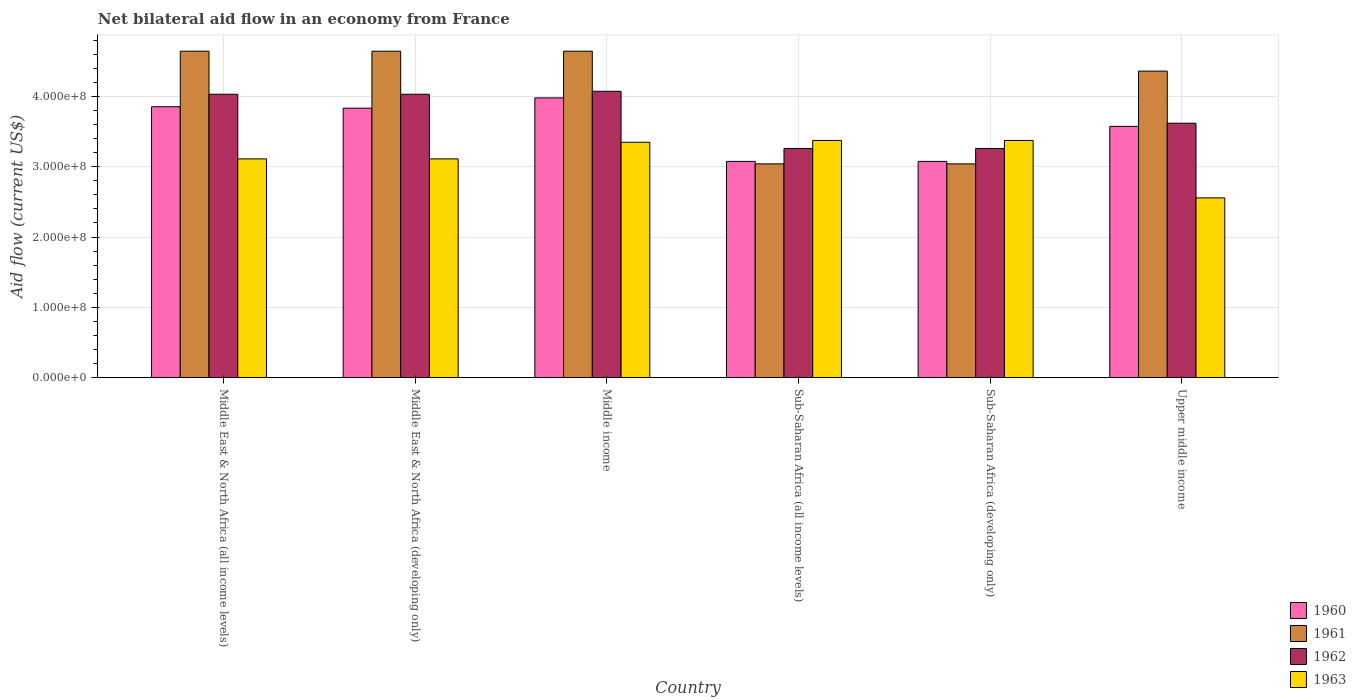How many different coloured bars are there?
Provide a short and direct response. 4. Are the number of bars per tick equal to the number of legend labels?
Your answer should be very brief. Yes. Are the number of bars on each tick of the X-axis equal?
Keep it short and to the point. Yes. How many bars are there on the 3rd tick from the left?
Make the answer very short. 4. What is the label of the 5th group of bars from the left?
Provide a succinct answer. Sub-Saharan Africa (developing only). In how many cases, is the number of bars for a given country not equal to the number of legend labels?
Keep it short and to the point. 0. What is the net bilateral aid flow in 1962 in Middle East & North Africa (developing only)?
Provide a succinct answer. 4.03e+08. Across all countries, what is the maximum net bilateral aid flow in 1960?
Provide a succinct answer. 3.98e+08. Across all countries, what is the minimum net bilateral aid flow in 1960?
Make the answer very short. 3.08e+08. In which country was the net bilateral aid flow in 1961 maximum?
Provide a short and direct response. Middle East & North Africa (all income levels). In which country was the net bilateral aid flow in 1960 minimum?
Give a very brief answer. Sub-Saharan Africa (all income levels). What is the total net bilateral aid flow in 1962 in the graph?
Your response must be concise. 2.23e+09. What is the difference between the net bilateral aid flow in 1960 in Middle East & North Africa (developing only) and that in Upper middle income?
Your answer should be very brief. 2.59e+07. What is the difference between the net bilateral aid flow in 1963 in Middle East & North Africa (all income levels) and the net bilateral aid flow in 1961 in Upper middle income?
Ensure brevity in your answer.  -1.25e+08. What is the average net bilateral aid flow in 1960 per country?
Provide a succinct answer. 3.56e+08. What is the difference between the net bilateral aid flow of/in 1961 and net bilateral aid flow of/in 1962 in Middle East & North Africa (all income levels)?
Your answer should be very brief. 6.12e+07. What is the ratio of the net bilateral aid flow in 1960 in Middle income to that in Upper middle income?
Provide a short and direct response. 1.11. Is the net bilateral aid flow in 1961 in Middle East & North Africa (all income levels) less than that in Sub-Saharan Africa (developing only)?
Make the answer very short. No. Is the difference between the net bilateral aid flow in 1961 in Middle East & North Africa (all income levels) and Middle East & North Africa (developing only) greater than the difference between the net bilateral aid flow in 1962 in Middle East & North Africa (all income levels) and Middle East & North Africa (developing only)?
Give a very brief answer. No. What is the difference between the highest and the second highest net bilateral aid flow in 1962?
Offer a very short reply. 4.20e+06. What is the difference between the highest and the lowest net bilateral aid flow in 1963?
Your response must be concise. 8.17e+07. Is it the case that in every country, the sum of the net bilateral aid flow in 1963 and net bilateral aid flow in 1961 is greater than the sum of net bilateral aid flow in 1962 and net bilateral aid flow in 1960?
Provide a succinct answer. No. How many countries are there in the graph?
Your answer should be very brief. 6. What is the difference between two consecutive major ticks on the Y-axis?
Your response must be concise. 1.00e+08. Are the values on the major ticks of Y-axis written in scientific E-notation?
Provide a short and direct response. Yes. Does the graph contain any zero values?
Make the answer very short. No. Does the graph contain grids?
Your answer should be very brief. Yes. How are the legend labels stacked?
Provide a short and direct response. Vertical. What is the title of the graph?
Your answer should be very brief. Net bilateral aid flow in an economy from France. Does "1998" appear as one of the legend labels in the graph?
Keep it short and to the point. No. What is the label or title of the Y-axis?
Provide a short and direct response. Aid flow (current US$). What is the Aid flow (current US$) in 1960 in Middle East & North Africa (all income levels)?
Give a very brief answer. 3.85e+08. What is the Aid flow (current US$) in 1961 in Middle East & North Africa (all income levels)?
Make the answer very short. 4.64e+08. What is the Aid flow (current US$) of 1962 in Middle East & North Africa (all income levels)?
Provide a succinct answer. 4.03e+08. What is the Aid flow (current US$) of 1963 in Middle East & North Africa (all income levels)?
Provide a short and direct response. 3.11e+08. What is the Aid flow (current US$) in 1960 in Middle East & North Africa (developing only)?
Offer a very short reply. 3.83e+08. What is the Aid flow (current US$) of 1961 in Middle East & North Africa (developing only)?
Ensure brevity in your answer.  4.64e+08. What is the Aid flow (current US$) of 1962 in Middle East & North Africa (developing only)?
Ensure brevity in your answer.  4.03e+08. What is the Aid flow (current US$) of 1963 in Middle East & North Africa (developing only)?
Offer a terse response. 3.11e+08. What is the Aid flow (current US$) of 1960 in Middle income?
Offer a very short reply. 3.98e+08. What is the Aid flow (current US$) of 1961 in Middle income?
Make the answer very short. 4.64e+08. What is the Aid flow (current US$) of 1962 in Middle income?
Provide a succinct answer. 4.07e+08. What is the Aid flow (current US$) in 1963 in Middle income?
Keep it short and to the point. 3.35e+08. What is the Aid flow (current US$) in 1960 in Sub-Saharan Africa (all income levels)?
Ensure brevity in your answer.  3.08e+08. What is the Aid flow (current US$) of 1961 in Sub-Saharan Africa (all income levels)?
Provide a succinct answer. 3.04e+08. What is the Aid flow (current US$) in 1962 in Sub-Saharan Africa (all income levels)?
Provide a succinct answer. 3.26e+08. What is the Aid flow (current US$) in 1963 in Sub-Saharan Africa (all income levels)?
Make the answer very short. 3.37e+08. What is the Aid flow (current US$) of 1960 in Sub-Saharan Africa (developing only)?
Give a very brief answer. 3.08e+08. What is the Aid flow (current US$) in 1961 in Sub-Saharan Africa (developing only)?
Your answer should be very brief. 3.04e+08. What is the Aid flow (current US$) in 1962 in Sub-Saharan Africa (developing only)?
Offer a very short reply. 3.26e+08. What is the Aid flow (current US$) of 1963 in Sub-Saharan Africa (developing only)?
Your response must be concise. 3.37e+08. What is the Aid flow (current US$) in 1960 in Upper middle income?
Ensure brevity in your answer.  3.57e+08. What is the Aid flow (current US$) in 1961 in Upper middle income?
Keep it short and to the point. 4.36e+08. What is the Aid flow (current US$) in 1962 in Upper middle income?
Provide a succinct answer. 3.62e+08. What is the Aid flow (current US$) in 1963 in Upper middle income?
Keep it short and to the point. 2.56e+08. Across all countries, what is the maximum Aid flow (current US$) in 1960?
Offer a very short reply. 3.98e+08. Across all countries, what is the maximum Aid flow (current US$) of 1961?
Keep it short and to the point. 4.64e+08. Across all countries, what is the maximum Aid flow (current US$) in 1962?
Offer a very short reply. 4.07e+08. Across all countries, what is the maximum Aid flow (current US$) of 1963?
Offer a terse response. 3.37e+08. Across all countries, what is the minimum Aid flow (current US$) in 1960?
Keep it short and to the point. 3.08e+08. Across all countries, what is the minimum Aid flow (current US$) in 1961?
Ensure brevity in your answer.  3.04e+08. Across all countries, what is the minimum Aid flow (current US$) in 1962?
Give a very brief answer. 3.26e+08. Across all countries, what is the minimum Aid flow (current US$) of 1963?
Your answer should be very brief. 2.56e+08. What is the total Aid flow (current US$) in 1960 in the graph?
Offer a very short reply. 2.14e+09. What is the total Aid flow (current US$) of 1961 in the graph?
Your response must be concise. 2.44e+09. What is the total Aid flow (current US$) of 1962 in the graph?
Your answer should be very brief. 2.23e+09. What is the total Aid flow (current US$) of 1963 in the graph?
Provide a short and direct response. 1.89e+09. What is the difference between the Aid flow (current US$) of 1962 in Middle East & North Africa (all income levels) and that in Middle East & North Africa (developing only)?
Your answer should be compact. 0. What is the difference between the Aid flow (current US$) of 1963 in Middle East & North Africa (all income levels) and that in Middle East & North Africa (developing only)?
Make the answer very short. 0. What is the difference between the Aid flow (current US$) in 1960 in Middle East & North Africa (all income levels) and that in Middle income?
Ensure brevity in your answer.  -1.26e+07. What is the difference between the Aid flow (current US$) in 1961 in Middle East & North Africa (all income levels) and that in Middle income?
Give a very brief answer. 0. What is the difference between the Aid flow (current US$) in 1962 in Middle East & North Africa (all income levels) and that in Middle income?
Ensure brevity in your answer.  -4.20e+06. What is the difference between the Aid flow (current US$) of 1963 in Middle East & North Africa (all income levels) and that in Middle income?
Ensure brevity in your answer.  -2.36e+07. What is the difference between the Aid flow (current US$) of 1960 in Middle East & North Africa (all income levels) and that in Sub-Saharan Africa (all income levels)?
Offer a very short reply. 7.77e+07. What is the difference between the Aid flow (current US$) in 1961 in Middle East & North Africa (all income levels) and that in Sub-Saharan Africa (all income levels)?
Offer a very short reply. 1.60e+08. What is the difference between the Aid flow (current US$) of 1962 in Middle East & North Africa (all income levels) and that in Sub-Saharan Africa (all income levels)?
Offer a very short reply. 7.71e+07. What is the difference between the Aid flow (current US$) of 1963 in Middle East & North Africa (all income levels) and that in Sub-Saharan Africa (all income levels)?
Offer a very short reply. -2.62e+07. What is the difference between the Aid flow (current US$) of 1960 in Middle East & North Africa (all income levels) and that in Sub-Saharan Africa (developing only)?
Provide a short and direct response. 7.77e+07. What is the difference between the Aid flow (current US$) of 1961 in Middle East & North Africa (all income levels) and that in Sub-Saharan Africa (developing only)?
Ensure brevity in your answer.  1.60e+08. What is the difference between the Aid flow (current US$) in 1962 in Middle East & North Africa (all income levels) and that in Sub-Saharan Africa (developing only)?
Provide a short and direct response. 7.71e+07. What is the difference between the Aid flow (current US$) in 1963 in Middle East & North Africa (all income levels) and that in Sub-Saharan Africa (developing only)?
Ensure brevity in your answer.  -2.62e+07. What is the difference between the Aid flow (current US$) in 1960 in Middle East & North Africa (all income levels) and that in Upper middle income?
Keep it short and to the point. 2.79e+07. What is the difference between the Aid flow (current US$) in 1961 in Middle East & North Africa (all income levels) and that in Upper middle income?
Provide a succinct answer. 2.83e+07. What is the difference between the Aid flow (current US$) of 1962 in Middle East & North Africa (all income levels) and that in Upper middle income?
Your answer should be very brief. 4.12e+07. What is the difference between the Aid flow (current US$) in 1963 in Middle East & North Africa (all income levels) and that in Upper middle income?
Offer a very short reply. 5.55e+07. What is the difference between the Aid flow (current US$) of 1960 in Middle East & North Africa (developing only) and that in Middle income?
Your answer should be very brief. -1.46e+07. What is the difference between the Aid flow (current US$) in 1962 in Middle East & North Africa (developing only) and that in Middle income?
Your response must be concise. -4.20e+06. What is the difference between the Aid flow (current US$) in 1963 in Middle East & North Africa (developing only) and that in Middle income?
Your answer should be very brief. -2.36e+07. What is the difference between the Aid flow (current US$) of 1960 in Middle East & North Africa (developing only) and that in Sub-Saharan Africa (all income levels)?
Give a very brief answer. 7.57e+07. What is the difference between the Aid flow (current US$) in 1961 in Middle East & North Africa (developing only) and that in Sub-Saharan Africa (all income levels)?
Ensure brevity in your answer.  1.60e+08. What is the difference between the Aid flow (current US$) in 1962 in Middle East & North Africa (developing only) and that in Sub-Saharan Africa (all income levels)?
Give a very brief answer. 7.71e+07. What is the difference between the Aid flow (current US$) of 1963 in Middle East & North Africa (developing only) and that in Sub-Saharan Africa (all income levels)?
Ensure brevity in your answer.  -2.62e+07. What is the difference between the Aid flow (current US$) of 1960 in Middle East & North Africa (developing only) and that in Sub-Saharan Africa (developing only)?
Your answer should be compact. 7.57e+07. What is the difference between the Aid flow (current US$) in 1961 in Middle East & North Africa (developing only) and that in Sub-Saharan Africa (developing only)?
Your answer should be compact. 1.60e+08. What is the difference between the Aid flow (current US$) in 1962 in Middle East & North Africa (developing only) and that in Sub-Saharan Africa (developing only)?
Provide a succinct answer. 7.71e+07. What is the difference between the Aid flow (current US$) in 1963 in Middle East & North Africa (developing only) and that in Sub-Saharan Africa (developing only)?
Give a very brief answer. -2.62e+07. What is the difference between the Aid flow (current US$) in 1960 in Middle East & North Africa (developing only) and that in Upper middle income?
Provide a short and direct response. 2.59e+07. What is the difference between the Aid flow (current US$) in 1961 in Middle East & North Africa (developing only) and that in Upper middle income?
Keep it short and to the point. 2.83e+07. What is the difference between the Aid flow (current US$) in 1962 in Middle East & North Africa (developing only) and that in Upper middle income?
Provide a short and direct response. 4.12e+07. What is the difference between the Aid flow (current US$) of 1963 in Middle East & North Africa (developing only) and that in Upper middle income?
Keep it short and to the point. 5.55e+07. What is the difference between the Aid flow (current US$) of 1960 in Middle income and that in Sub-Saharan Africa (all income levels)?
Give a very brief answer. 9.03e+07. What is the difference between the Aid flow (current US$) in 1961 in Middle income and that in Sub-Saharan Africa (all income levels)?
Give a very brief answer. 1.60e+08. What is the difference between the Aid flow (current US$) of 1962 in Middle income and that in Sub-Saharan Africa (all income levels)?
Give a very brief answer. 8.13e+07. What is the difference between the Aid flow (current US$) in 1963 in Middle income and that in Sub-Saharan Africa (all income levels)?
Make the answer very short. -2.60e+06. What is the difference between the Aid flow (current US$) in 1960 in Middle income and that in Sub-Saharan Africa (developing only)?
Keep it short and to the point. 9.03e+07. What is the difference between the Aid flow (current US$) of 1961 in Middle income and that in Sub-Saharan Africa (developing only)?
Your answer should be compact. 1.60e+08. What is the difference between the Aid flow (current US$) in 1962 in Middle income and that in Sub-Saharan Africa (developing only)?
Give a very brief answer. 8.13e+07. What is the difference between the Aid flow (current US$) in 1963 in Middle income and that in Sub-Saharan Africa (developing only)?
Your answer should be compact. -2.60e+06. What is the difference between the Aid flow (current US$) in 1960 in Middle income and that in Upper middle income?
Your answer should be very brief. 4.05e+07. What is the difference between the Aid flow (current US$) of 1961 in Middle income and that in Upper middle income?
Ensure brevity in your answer.  2.83e+07. What is the difference between the Aid flow (current US$) of 1962 in Middle income and that in Upper middle income?
Provide a short and direct response. 4.54e+07. What is the difference between the Aid flow (current US$) in 1963 in Middle income and that in Upper middle income?
Offer a terse response. 7.91e+07. What is the difference between the Aid flow (current US$) of 1960 in Sub-Saharan Africa (all income levels) and that in Sub-Saharan Africa (developing only)?
Offer a very short reply. 0. What is the difference between the Aid flow (current US$) in 1961 in Sub-Saharan Africa (all income levels) and that in Sub-Saharan Africa (developing only)?
Make the answer very short. 0. What is the difference between the Aid flow (current US$) in 1962 in Sub-Saharan Africa (all income levels) and that in Sub-Saharan Africa (developing only)?
Keep it short and to the point. 0. What is the difference between the Aid flow (current US$) in 1960 in Sub-Saharan Africa (all income levels) and that in Upper middle income?
Your answer should be compact. -4.98e+07. What is the difference between the Aid flow (current US$) of 1961 in Sub-Saharan Africa (all income levels) and that in Upper middle income?
Provide a short and direct response. -1.32e+08. What is the difference between the Aid flow (current US$) of 1962 in Sub-Saharan Africa (all income levels) and that in Upper middle income?
Offer a terse response. -3.59e+07. What is the difference between the Aid flow (current US$) of 1963 in Sub-Saharan Africa (all income levels) and that in Upper middle income?
Offer a very short reply. 8.17e+07. What is the difference between the Aid flow (current US$) in 1960 in Sub-Saharan Africa (developing only) and that in Upper middle income?
Your answer should be very brief. -4.98e+07. What is the difference between the Aid flow (current US$) of 1961 in Sub-Saharan Africa (developing only) and that in Upper middle income?
Give a very brief answer. -1.32e+08. What is the difference between the Aid flow (current US$) in 1962 in Sub-Saharan Africa (developing only) and that in Upper middle income?
Ensure brevity in your answer.  -3.59e+07. What is the difference between the Aid flow (current US$) in 1963 in Sub-Saharan Africa (developing only) and that in Upper middle income?
Ensure brevity in your answer.  8.17e+07. What is the difference between the Aid flow (current US$) in 1960 in Middle East & North Africa (all income levels) and the Aid flow (current US$) in 1961 in Middle East & North Africa (developing only)?
Your answer should be compact. -7.90e+07. What is the difference between the Aid flow (current US$) of 1960 in Middle East & North Africa (all income levels) and the Aid flow (current US$) of 1962 in Middle East & North Africa (developing only)?
Ensure brevity in your answer.  -1.78e+07. What is the difference between the Aid flow (current US$) in 1960 in Middle East & North Africa (all income levels) and the Aid flow (current US$) in 1963 in Middle East & North Africa (developing only)?
Your answer should be very brief. 7.41e+07. What is the difference between the Aid flow (current US$) of 1961 in Middle East & North Africa (all income levels) and the Aid flow (current US$) of 1962 in Middle East & North Africa (developing only)?
Your response must be concise. 6.12e+07. What is the difference between the Aid flow (current US$) in 1961 in Middle East & North Africa (all income levels) and the Aid flow (current US$) in 1963 in Middle East & North Africa (developing only)?
Your answer should be compact. 1.53e+08. What is the difference between the Aid flow (current US$) of 1962 in Middle East & North Africa (all income levels) and the Aid flow (current US$) of 1963 in Middle East & North Africa (developing only)?
Provide a short and direct response. 9.19e+07. What is the difference between the Aid flow (current US$) in 1960 in Middle East & North Africa (all income levels) and the Aid flow (current US$) in 1961 in Middle income?
Your answer should be very brief. -7.90e+07. What is the difference between the Aid flow (current US$) of 1960 in Middle East & North Africa (all income levels) and the Aid flow (current US$) of 1962 in Middle income?
Ensure brevity in your answer.  -2.20e+07. What is the difference between the Aid flow (current US$) of 1960 in Middle East & North Africa (all income levels) and the Aid flow (current US$) of 1963 in Middle income?
Offer a terse response. 5.05e+07. What is the difference between the Aid flow (current US$) in 1961 in Middle East & North Africa (all income levels) and the Aid flow (current US$) in 1962 in Middle income?
Give a very brief answer. 5.70e+07. What is the difference between the Aid flow (current US$) in 1961 in Middle East & North Africa (all income levels) and the Aid flow (current US$) in 1963 in Middle income?
Your response must be concise. 1.30e+08. What is the difference between the Aid flow (current US$) of 1962 in Middle East & North Africa (all income levels) and the Aid flow (current US$) of 1963 in Middle income?
Offer a terse response. 6.83e+07. What is the difference between the Aid flow (current US$) in 1960 in Middle East & North Africa (all income levels) and the Aid flow (current US$) in 1961 in Sub-Saharan Africa (all income levels)?
Ensure brevity in your answer.  8.12e+07. What is the difference between the Aid flow (current US$) of 1960 in Middle East & North Africa (all income levels) and the Aid flow (current US$) of 1962 in Sub-Saharan Africa (all income levels)?
Give a very brief answer. 5.93e+07. What is the difference between the Aid flow (current US$) of 1960 in Middle East & North Africa (all income levels) and the Aid flow (current US$) of 1963 in Sub-Saharan Africa (all income levels)?
Provide a short and direct response. 4.79e+07. What is the difference between the Aid flow (current US$) in 1961 in Middle East & North Africa (all income levels) and the Aid flow (current US$) in 1962 in Sub-Saharan Africa (all income levels)?
Make the answer very short. 1.38e+08. What is the difference between the Aid flow (current US$) of 1961 in Middle East & North Africa (all income levels) and the Aid flow (current US$) of 1963 in Sub-Saharan Africa (all income levels)?
Provide a succinct answer. 1.27e+08. What is the difference between the Aid flow (current US$) of 1962 in Middle East & North Africa (all income levels) and the Aid flow (current US$) of 1963 in Sub-Saharan Africa (all income levels)?
Offer a very short reply. 6.57e+07. What is the difference between the Aid flow (current US$) in 1960 in Middle East & North Africa (all income levels) and the Aid flow (current US$) in 1961 in Sub-Saharan Africa (developing only)?
Provide a succinct answer. 8.12e+07. What is the difference between the Aid flow (current US$) in 1960 in Middle East & North Africa (all income levels) and the Aid flow (current US$) in 1962 in Sub-Saharan Africa (developing only)?
Your response must be concise. 5.93e+07. What is the difference between the Aid flow (current US$) in 1960 in Middle East & North Africa (all income levels) and the Aid flow (current US$) in 1963 in Sub-Saharan Africa (developing only)?
Provide a succinct answer. 4.79e+07. What is the difference between the Aid flow (current US$) in 1961 in Middle East & North Africa (all income levels) and the Aid flow (current US$) in 1962 in Sub-Saharan Africa (developing only)?
Offer a very short reply. 1.38e+08. What is the difference between the Aid flow (current US$) of 1961 in Middle East & North Africa (all income levels) and the Aid flow (current US$) of 1963 in Sub-Saharan Africa (developing only)?
Provide a succinct answer. 1.27e+08. What is the difference between the Aid flow (current US$) in 1962 in Middle East & North Africa (all income levels) and the Aid flow (current US$) in 1963 in Sub-Saharan Africa (developing only)?
Provide a short and direct response. 6.57e+07. What is the difference between the Aid flow (current US$) in 1960 in Middle East & North Africa (all income levels) and the Aid flow (current US$) in 1961 in Upper middle income?
Your answer should be compact. -5.07e+07. What is the difference between the Aid flow (current US$) of 1960 in Middle East & North Africa (all income levels) and the Aid flow (current US$) of 1962 in Upper middle income?
Ensure brevity in your answer.  2.34e+07. What is the difference between the Aid flow (current US$) in 1960 in Middle East & North Africa (all income levels) and the Aid flow (current US$) in 1963 in Upper middle income?
Your answer should be compact. 1.30e+08. What is the difference between the Aid flow (current US$) of 1961 in Middle East & North Africa (all income levels) and the Aid flow (current US$) of 1962 in Upper middle income?
Give a very brief answer. 1.02e+08. What is the difference between the Aid flow (current US$) in 1961 in Middle East & North Africa (all income levels) and the Aid flow (current US$) in 1963 in Upper middle income?
Ensure brevity in your answer.  2.09e+08. What is the difference between the Aid flow (current US$) of 1962 in Middle East & North Africa (all income levels) and the Aid flow (current US$) of 1963 in Upper middle income?
Provide a short and direct response. 1.47e+08. What is the difference between the Aid flow (current US$) in 1960 in Middle East & North Africa (developing only) and the Aid flow (current US$) in 1961 in Middle income?
Make the answer very short. -8.10e+07. What is the difference between the Aid flow (current US$) in 1960 in Middle East & North Africa (developing only) and the Aid flow (current US$) in 1962 in Middle income?
Your answer should be compact. -2.40e+07. What is the difference between the Aid flow (current US$) of 1960 in Middle East & North Africa (developing only) and the Aid flow (current US$) of 1963 in Middle income?
Your answer should be very brief. 4.85e+07. What is the difference between the Aid flow (current US$) of 1961 in Middle East & North Africa (developing only) and the Aid flow (current US$) of 1962 in Middle income?
Your answer should be very brief. 5.70e+07. What is the difference between the Aid flow (current US$) in 1961 in Middle East & North Africa (developing only) and the Aid flow (current US$) in 1963 in Middle income?
Offer a terse response. 1.30e+08. What is the difference between the Aid flow (current US$) of 1962 in Middle East & North Africa (developing only) and the Aid flow (current US$) of 1963 in Middle income?
Keep it short and to the point. 6.83e+07. What is the difference between the Aid flow (current US$) of 1960 in Middle East & North Africa (developing only) and the Aid flow (current US$) of 1961 in Sub-Saharan Africa (all income levels)?
Your answer should be very brief. 7.92e+07. What is the difference between the Aid flow (current US$) of 1960 in Middle East & North Africa (developing only) and the Aid flow (current US$) of 1962 in Sub-Saharan Africa (all income levels)?
Offer a very short reply. 5.73e+07. What is the difference between the Aid flow (current US$) of 1960 in Middle East & North Africa (developing only) and the Aid flow (current US$) of 1963 in Sub-Saharan Africa (all income levels)?
Your answer should be very brief. 4.59e+07. What is the difference between the Aid flow (current US$) in 1961 in Middle East & North Africa (developing only) and the Aid flow (current US$) in 1962 in Sub-Saharan Africa (all income levels)?
Ensure brevity in your answer.  1.38e+08. What is the difference between the Aid flow (current US$) of 1961 in Middle East & North Africa (developing only) and the Aid flow (current US$) of 1963 in Sub-Saharan Africa (all income levels)?
Ensure brevity in your answer.  1.27e+08. What is the difference between the Aid flow (current US$) of 1962 in Middle East & North Africa (developing only) and the Aid flow (current US$) of 1963 in Sub-Saharan Africa (all income levels)?
Give a very brief answer. 6.57e+07. What is the difference between the Aid flow (current US$) of 1960 in Middle East & North Africa (developing only) and the Aid flow (current US$) of 1961 in Sub-Saharan Africa (developing only)?
Your answer should be compact. 7.92e+07. What is the difference between the Aid flow (current US$) in 1960 in Middle East & North Africa (developing only) and the Aid flow (current US$) in 1962 in Sub-Saharan Africa (developing only)?
Ensure brevity in your answer.  5.73e+07. What is the difference between the Aid flow (current US$) of 1960 in Middle East & North Africa (developing only) and the Aid flow (current US$) of 1963 in Sub-Saharan Africa (developing only)?
Provide a succinct answer. 4.59e+07. What is the difference between the Aid flow (current US$) in 1961 in Middle East & North Africa (developing only) and the Aid flow (current US$) in 1962 in Sub-Saharan Africa (developing only)?
Keep it short and to the point. 1.38e+08. What is the difference between the Aid flow (current US$) in 1961 in Middle East & North Africa (developing only) and the Aid flow (current US$) in 1963 in Sub-Saharan Africa (developing only)?
Offer a terse response. 1.27e+08. What is the difference between the Aid flow (current US$) of 1962 in Middle East & North Africa (developing only) and the Aid flow (current US$) of 1963 in Sub-Saharan Africa (developing only)?
Offer a very short reply. 6.57e+07. What is the difference between the Aid flow (current US$) of 1960 in Middle East & North Africa (developing only) and the Aid flow (current US$) of 1961 in Upper middle income?
Offer a terse response. -5.27e+07. What is the difference between the Aid flow (current US$) of 1960 in Middle East & North Africa (developing only) and the Aid flow (current US$) of 1962 in Upper middle income?
Give a very brief answer. 2.14e+07. What is the difference between the Aid flow (current US$) of 1960 in Middle East & North Africa (developing only) and the Aid flow (current US$) of 1963 in Upper middle income?
Offer a terse response. 1.28e+08. What is the difference between the Aid flow (current US$) of 1961 in Middle East & North Africa (developing only) and the Aid flow (current US$) of 1962 in Upper middle income?
Your answer should be very brief. 1.02e+08. What is the difference between the Aid flow (current US$) of 1961 in Middle East & North Africa (developing only) and the Aid flow (current US$) of 1963 in Upper middle income?
Give a very brief answer. 2.09e+08. What is the difference between the Aid flow (current US$) in 1962 in Middle East & North Africa (developing only) and the Aid flow (current US$) in 1963 in Upper middle income?
Provide a succinct answer. 1.47e+08. What is the difference between the Aid flow (current US$) in 1960 in Middle income and the Aid flow (current US$) in 1961 in Sub-Saharan Africa (all income levels)?
Provide a short and direct response. 9.38e+07. What is the difference between the Aid flow (current US$) of 1960 in Middle income and the Aid flow (current US$) of 1962 in Sub-Saharan Africa (all income levels)?
Ensure brevity in your answer.  7.19e+07. What is the difference between the Aid flow (current US$) of 1960 in Middle income and the Aid flow (current US$) of 1963 in Sub-Saharan Africa (all income levels)?
Keep it short and to the point. 6.05e+07. What is the difference between the Aid flow (current US$) in 1961 in Middle income and the Aid flow (current US$) in 1962 in Sub-Saharan Africa (all income levels)?
Provide a succinct answer. 1.38e+08. What is the difference between the Aid flow (current US$) of 1961 in Middle income and the Aid flow (current US$) of 1963 in Sub-Saharan Africa (all income levels)?
Keep it short and to the point. 1.27e+08. What is the difference between the Aid flow (current US$) in 1962 in Middle income and the Aid flow (current US$) in 1963 in Sub-Saharan Africa (all income levels)?
Ensure brevity in your answer.  6.99e+07. What is the difference between the Aid flow (current US$) of 1960 in Middle income and the Aid flow (current US$) of 1961 in Sub-Saharan Africa (developing only)?
Offer a very short reply. 9.38e+07. What is the difference between the Aid flow (current US$) in 1960 in Middle income and the Aid flow (current US$) in 1962 in Sub-Saharan Africa (developing only)?
Provide a succinct answer. 7.19e+07. What is the difference between the Aid flow (current US$) in 1960 in Middle income and the Aid flow (current US$) in 1963 in Sub-Saharan Africa (developing only)?
Your answer should be very brief. 6.05e+07. What is the difference between the Aid flow (current US$) in 1961 in Middle income and the Aid flow (current US$) in 1962 in Sub-Saharan Africa (developing only)?
Keep it short and to the point. 1.38e+08. What is the difference between the Aid flow (current US$) of 1961 in Middle income and the Aid flow (current US$) of 1963 in Sub-Saharan Africa (developing only)?
Offer a terse response. 1.27e+08. What is the difference between the Aid flow (current US$) of 1962 in Middle income and the Aid flow (current US$) of 1963 in Sub-Saharan Africa (developing only)?
Your answer should be compact. 6.99e+07. What is the difference between the Aid flow (current US$) in 1960 in Middle income and the Aid flow (current US$) in 1961 in Upper middle income?
Your answer should be very brief. -3.81e+07. What is the difference between the Aid flow (current US$) of 1960 in Middle income and the Aid flow (current US$) of 1962 in Upper middle income?
Provide a succinct answer. 3.60e+07. What is the difference between the Aid flow (current US$) of 1960 in Middle income and the Aid flow (current US$) of 1963 in Upper middle income?
Offer a very short reply. 1.42e+08. What is the difference between the Aid flow (current US$) of 1961 in Middle income and the Aid flow (current US$) of 1962 in Upper middle income?
Offer a terse response. 1.02e+08. What is the difference between the Aid flow (current US$) in 1961 in Middle income and the Aid flow (current US$) in 1963 in Upper middle income?
Your response must be concise. 2.09e+08. What is the difference between the Aid flow (current US$) in 1962 in Middle income and the Aid flow (current US$) in 1963 in Upper middle income?
Offer a terse response. 1.52e+08. What is the difference between the Aid flow (current US$) in 1960 in Sub-Saharan Africa (all income levels) and the Aid flow (current US$) in 1961 in Sub-Saharan Africa (developing only)?
Ensure brevity in your answer.  3.50e+06. What is the difference between the Aid flow (current US$) of 1960 in Sub-Saharan Africa (all income levels) and the Aid flow (current US$) of 1962 in Sub-Saharan Africa (developing only)?
Keep it short and to the point. -1.84e+07. What is the difference between the Aid flow (current US$) of 1960 in Sub-Saharan Africa (all income levels) and the Aid flow (current US$) of 1963 in Sub-Saharan Africa (developing only)?
Your answer should be very brief. -2.98e+07. What is the difference between the Aid flow (current US$) of 1961 in Sub-Saharan Africa (all income levels) and the Aid flow (current US$) of 1962 in Sub-Saharan Africa (developing only)?
Your answer should be very brief. -2.19e+07. What is the difference between the Aid flow (current US$) of 1961 in Sub-Saharan Africa (all income levels) and the Aid flow (current US$) of 1963 in Sub-Saharan Africa (developing only)?
Provide a succinct answer. -3.33e+07. What is the difference between the Aid flow (current US$) in 1962 in Sub-Saharan Africa (all income levels) and the Aid flow (current US$) in 1963 in Sub-Saharan Africa (developing only)?
Give a very brief answer. -1.14e+07. What is the difference between the Aid flow (current US$) of 1960 in Sub-Saharan Africa (all income levels) and the Aid flow (current US$) of 1961 in Upper middle income?
Offer a terse response. -1.28e+08. What is the difference between the Aid flow (current US$) of 1960 in Sub-Saharan Africa (all income levels) and the Aid flow (current US$) of 1962 in Upper middle income?
Offer a very short reply. -5.43e+07. What is the difference between the Aid flow (current US$) of 1960 in Sub-Saharan Africa (all income levels) and the Aid flow (current US$) of 1963 in Upper middle income?
Make the answer very short. 5.19e+07. What is the difference between the Aid flow (current US$) of 1961 in Sub-Saharan Africa (all income levels) and the Aid flow (current US$) of 1962 in Upper middle income?
Your response must be concise. -5.78e+07. What is the difference between the Aid flow (current US$) in 1961 in Sub-Saharan Africa (all income levels) and the Aid flow (current US$) in 1963 in Upper middle income?
Your answer should be compact. 4.84e+07. What is the difference between the Aid flow (current US$) of 1962 in Sub-Saharan Africa (all income levels) and the Aid flow (current US$) of 1963 in Upper middle income?
Keep it short and to the point. 7.03e+07. What is the difference between the Aid flow (current US$) of 1960 in Sub-Saharan Africa (developing only) and the Aid flow (current US$) of 1961 in Upper middle income?
Your answer should be compact. -1.28e+08. What is the difference between the Aid flow (current US$) of 1960 in Sub-Saharan Africa (developing only) and the Aid flow (current US$) of 1962 in Upper middle income?
Your response must be concise. -5.43e+07. What is the difference between the Aid flow (current US$) in 1960 in Sub-Saharan Africa (developing only) and the Aid flow (current US$) in 1963 in Upper middle income?
Provide a succinct answer. 5.19e+07. What is the difference between the Aid flow (current US$) of 1961 in Sub-Saharan Africa (developing only) and the Aid flow (current US$) of 1962 in Upper middle income?
Offer a very short reply. -5.78e+07. What is the difference between the Aid flow (current US$) in 1961 in Sub-Saharan Africa (developing only) and the Aid flow (current US$) in 1963 in Upper middle income?
Ensure brevity in your answer.  4.84e+07. What is the difference between the Aid flow (current US$) of 1962 in Sub-Saharan Africa (developing only) and the Aid flow (current US$) of 1963 in Upper middle income?
Provide a short and direct response. 7.03e+07. What is the average Aid flow (current US$) of 1960 per country?
Give a very brief answer. 3.56e+08. What is the average Aid flow (current US$) of 1961 per country?
Make the answer very short. 4.06e+08. What is the average Aid flow (current US$) in 1962 per country?
Your answer should be compact. 3.71e+08. What is the average Aid flow (current US$) in 1963 per country?
Ensure brevity in your answer.  3.15e+08. What is the difference between the Aid flow (current US$) in 1960 and Aid flow (current US$) in 1961 in Middle East & North Africa (all income levels)?
Offer a terse response. -7.90e+07. What is the difference between the Aid flow (current US$) of 1960 and Aid flow (current US$) of 1962 in Middle East & North Africa (all income levels)?
Give a very brief answer. -1.78e+07. What is the difference between the Aid flow (current US$) of 1960 and Aid flow (current US$) of 1963 in Middle East & North Africa (all income levels)?
Provide a succinct answer. 7.41e+07. What is the difference between the Aid flow (current US$) in 1961 and Aid flow (current US$) in 1962 in Middle East & North Africa (all income levels)?
Provide a short and direct response. 6.12e+07. What is the difference between the Aid flow (current US$) in 1961 and Aid flow (current US$) in 1963 in Middle East & North Africa (all income levels)?
Keep it short and to the point. 1.53e+08. What is the difference between the Aid flow (current US$) in 1962 and Aid flow (current US$) in 1963 in Middle East & North Africa (all income levels)?
Provide a short and direct response. 9.19e+07. What is the difference between the Aid flow (current US$) of 1960 and Aid flow (current US$) of 1961 in Middle East & North Africa (developing only)?
Your response must be concise. -8.10e+07. What is the difference between the Aid flow (current US$) in 1960 and Aid flow (current US$) in 1962 in Middle East & North Africa (developing only)?
Your response must be concise. -1.98e+07. What is the difference between the Aid flow (current US$) in 1960 and Aid flow (current US$) in 1963 in Middle East & North Africa (developing only)?
Your response must be concise. 7.21e+07. What is the difference between the Aid flow (current US$) of 1961 and Aid flow (current US$) of 1962 in Middle East & North Africa (developing only)?
Provide a succinct answer. 6.12e+07. What is the difference between the Aid flow (current US$) of 1961 and Aid flow (current US$) of 1963 in Middle East & North Africa (developing only)?
Your answer should be compact. 1.53e+08. What is the difference between the Aid flow (current US$) in 1962 and Aid flow (current US$) in 1963 in Middle East & North Africa (developing only)?
Give a very brief answer. 9.19e+07. What is the difference between the Aid flow (current US$) in 1960 and Aid flow (current US$) in 1961 in Middle income?
Your response must be concise. -6.64e+07. What is the difference between the Aid flow (current US$) of 1960 and Aid flow (current US$) of 1962 in Middle income?
Offer a very short reply. -9.40e+06. What is the difference between the Aid flow (current US$) of 1960 and Aid flow (current US$) of 1963 in Middle income?
Provide a succinct answer. 6.31e+07. What is the difference between the Aid flow (current US$) in 1961 and Aid flow (current US$) in 1962 in Middle income?
Keep it short and to the point. 5.70e+07. What is the difference between the Aid flow (current US$) of 1961 and Aid flow (current US$) of 1963 in Middle income?
Your answer should be compact. 1.30e+08. What is the difference between the Aid flow (current US$) of 1962 and Aid flow (current US$) of 1963 in Middle income?
Offer a terse response. 7.25e+07. What is the difference between the Aid flow (current US$) of 1960 and Aid flow (current US$) of 1961 in Sub-Saharan Africa (all income levels)?
Your response must be concise. 3.50e+06. What is the difference between the Aid flow (current US$) in 1960 and Aid flow (current US$) in 1962 in Sub-Saharan Africa (all income levels)?
Offer a very short reply. -1.84e+07. What is the difference between the Aid flow (current US$) in 1960 and Aid flow (current US$) in 1963 in Sub-Saharan Africa (all income levels)?
Give a very brief answer. -2.98e+07. What is the difference between the Aid flow (current US$) of 1961 and Aid flow (current US$) of 1962 in Sub-Saharan Africa (all income levels)?
Provide a succinct answer. -2.19e+07. What is the difference between the Aid flow (current US$) in 1961 and Aid flow (current US$) in 1963 in Sub-Saharan Africa (all income levels)?
Provide a short and direct response. -3.33e+07. What is the difference between the Aid flow (current US$) in 1962 and Aid flow (current US$) in 1963 in Sub-Saharan Africa (all income levels)?
Your answer should be compact. -1.14e+07. What is the difference between the Aid flow (current US$) in 1960 and Aid flow (current US$) in 1961 in Sub-Saharan Africa (developing only)?
Your answer should be compact. 3.50e+06. What is the difference between the Aid flow (current US$) in 1960 and Aid flow (current US$) in 1962 in Sub-Saharan Africa (developing only)?
Offer a terse response. -1.84e+07. What is the difference between the Aid flow (current US$) of 1960 and Aid flow (current US$) of 1963 in Sub-Saharan Africa (developing only)?
Make the answer very short. -2.98e+07. What is the difference between the Aid flow (current US$) of 1961 and Aid flow (current US$) of 1962 in Sub-Saharan Africa (developing only)?
Offer a very short reply. -2.19e+07. What is the difference between the Aid flow (current US$) of 1961 and Aid flow (current US$) of 1963 in Sub-Saharan Africa (developing only)?
Provide a short and direct response. -3.33e+07. What is the difference between the Aid flow (current US$) of 1962 and Aid flow (current US$) of 1963 in Sub-Saharan Africa (developing only)?
Offer a very short reply. -1.14e+07. What is the difference between the Aid flow (current US$) in 1960 and Aid flow (current US$) in 1961 in Upper middle income?
Provide a succinct answer. -7.86e+07. What is the difference between the Aid flow (current US$) of 1960 and Aid flow (current US$) of 1962 in Upper middle income?
Provide a succinct answer. -4.50e+06. What is the difference between the Aid flow (current US$) of 1960 and Aid flow (current US$) of 1963 in Upper middle income?
Your response must be concise. 1.02e+08. What is the difference between the Aid flow (current US$) of 1961 and Aid flow (current US$) of 1962 in Upper middle income?
Make the answer very short. 7.41e+07. What is the difference between the Aid flow (current US$) in 1961 and Aid flow (current US$) in 1963 in Upper middle income?
Ensure brevity in your answer.  1.80e+08. What is the difference between the Aid flow (current US$) of 1962 and Aid flow (current US$) of 1963 in Upper middle income?
Give a very brief answer. 1.06e+08. What is the ratio of the Aid flow (current US$) of 1962 in Middle East & North Africa (all income levels) to that in Middle East & North Africa (developing only)?
Your answer should be compact. 1. What is the ratio of the Aid flow (current US$) in 1960 in Middle East & North Africa (all income levels) to that in Middle income?
Offer a terse response. 0.97. What is the ratio of the Aid flow (current US$) in 1961 in Middle East & North Africa (all income levels) to that in Middle income?
Keep it short and to the point. 1. What is the ratio of the Aid flow (current US$) in 1962 in Middle East & North Africa (all income levels) to that in Middle income?
Provide a succinct answer. 0.99. What is the ratio of the Aid flow (current US$) of 1963 in Middle East & North Africa (all income levels) to that in Middle income?
Offer a terse response. 0.93. What is the ratio of the Aid flow (current US$) in 1960 in Middle East & North Africa (all income levels) to that in Sub-Saharan Africa (all income levels)?
Provide a succinct answer. 1.25. What is the ratio of the Aid flow (current US$) of 1961 in Middle East & North Africa (all income levels) to that in Sub-Saharan Africa (all income levels)?
Ensure brevity in your answer.  1.53. What is the ratio of the Aid flow (current US$) in 1962 in Middle East & North Africa (all income levels) to that in Sub-Saharan Africa (all income levels)?
Provide a short and direct response. 1.24. What is the ratio of the Aid flow (current US$) of 1963 in Middle East & North Africa (all income levels) to that in Sub-Saharan Africa (all income levels)?
Give a very brief answer. 0.92. What is the ratio of the Aid flow (current US$) of 1960 in Middle East & North Africa (all income levels) to that in Sub-Saharan Africa (developing only)?
Keep it short and to the point. 1.25. What is the ratio of the Aid flow (current US$) of 1961 in Middle East & North Africa (all income levels) to that in Sub-Saharan Africa (developing only)?
Offer a terse response. 1.53. What is the ratio of the Aid flow (current US$) of 1962 in Middle East & North Africa (all income levels) to that in Sub-Saharan Africa (developing only)?
Make the answer very short. 1.24. What is the ratio of the Aid flow (current US$) of 1963 in Middle East & North Africa (all income levels) to that in Sub-Saharan Africa (developing only)?
Your answer should be compact. 0.92. What is the ratio of the Aid flow (current US$) in 1960 in Middle East & North Africa (all income levels) to that in Upper middle income?
Offer a terse response. 1.08. What is the ratio of the Aid flow (current US$) in 1961 in Middle East & North Africa (all income levels) to that in Upper middle income?
Your response must be concise. 1.06. What is the ratio of the Aid flow (current US$) of 1962 in Middle East & North Africa (all income levels) to that in Upper middle income?
Ensure brevity in your answer.  1.11. What is the ratio of the Aid flow (current US$) in 1963 in Middle East & North Africa (all income levels) to that in Upper middle income?
Keep it short and to the point. 1.22. What is the ratio of the Aid flow (current US$) of 1960 in Middle East & North Africa (developing only) to that in Middle income?
Your answer should be very brief. 0.96. What is the ratio of the Aid flow (current US$) of 1962 in Middle East & North Africa (developing only) to that in Middle income?
Make the answer very short. 0.99. What is the ratio of the Aid flow (current US$) in 1963 in Middle East & North Africa (developing only) to that in Middle income?
Offer a terse response. 0.93. What is the ratio of the Aid flow (current US$) of 1960 in Middle East & North Africa (developing only) to that in Sub-Saharan Africa (all income levels)?
Make the answer very short. 1.25. What is the ratio of the Aid flow (current US$) in 1961 in Middle East & North Africa (developing only) to that in Sub-Saharan Africa (all income levels)?
Give a very brief answer. 1.53. What is the ratio of the Aid flow (current US$) in 1962 in Middle East & North Africa (developing only) to that in Sub-Saharan Africa (all income levels)?
Make the answer very short. 1.24. What is the ratio of the Aid flow (current US$) in 1963 in Middle East & North Africa (developing only) to that in Sub-Saharan Africa (all income levels)?
Provide a succinct answer. 0.92. What is the ratio of the Aid flow (current US$) of 1960 in Middle East & North Africa (developing only) to that in Sub-Saharan Africa (developing only)?
Offer a terse response. 1.25. What is the ratio of the Aid flow (current US$) of 1961 in Middle East & North Africa (developing only) to that in Sub-Saharan Africa (developing only)?
Your response must be concise. 1.53. What is the ratio of the Aid flow (current US$) of 1962 in Middle East & North Africa (developing only) to that in Sub-Saharan Africa (developing only)?
Ensure brevity in your answer.  1.24. What is the ratio of the Aid flow (current US$) in 1963 in Middle East & North Africa (developing only) to that in Sub-Saharan Africa (developing only)?
Provide a succinct answer. 0.92. What is the ratio of the Aid flow (current US$) of 1960 in Middle East & North Africa (developing only) to that in Upper middle income?
Offer a terse response. 1.07. What is the ratio of the Aid flow (current US$) of 1961 in Middle East & North Africa (developing only) to that in Upper middle income?
Your response must be concise. 1.06. What is the ratio of the Aid flow (current US$) of 1962 in Middle East & North Africa (developing only) to that in Upper middle income?
Give a very brief answer. 1.11. What is the ratio of the Aid flow (current US$) of 1963 in Middle East & North Africa (developing only) to that in Upper middle income?
Give a very brief answer. 1.22. What is the ratio of the Aid flow (current US$) in 1960 in Middle income to that in Sub-Saharan Africa (all income levels)?
Make the answer very short. 1.29. What is the ratio of the Aid flow (current US$) in 1961 in Middle income to that in Sub-Saharan Africa (all income levels)?
Your answer should be very brief. 1.53. What is the ratio of the Aid flow (current US$) in 1962 in Middle income to that in Sub-Saharan Africa (all income levels)?
Make the answer very short. 1.25. What is the ratio of the Aid flow (current US$) in 1963 in Middle income to that in Sub-Saharan Africa (all income levels)?
Ensure brevity in your answer.  0.99. What is the ratio of the Aid flow (current US$) of 1960 in Middle income to that in Sub-Saharan Africa (developing only)?
Your answer should be compact. 1.29. What is the ratio of the Aid flow (current US$) in 1961 in Middle income to that in Sub-Saharan Africa (developing only)?
Give a very brief answer. 1.53. What is the ratio of the Aid flow (current US$) in 1962 in Middle income to that in Sub-Saharan Africa (developing only)?
Keep it short and to the point. 1.25. What is the ratio of the Aid flow (current US$) in 1960 in Middle income to that in Upper middle income?
Keep it short and to the point. 1.11. What is the ratio of the Aid flow (current US$) of 1961 in Middle income to that in Upper middle income?
Ensure brevity in your answer.  1.06. What is the ratio of the Aid flow (current US$) of 1962 in Middle income to that in Upper middle income?
Provide a short and direct response. 1.13. What is the ratio of the Aid flow (current US$) of 1963 in Middle income to that in Upper middle income?
Offer a very short reply. 1.31. What is the ratio of the Aid flow (current US$) of 1960 in Sub-Saharan Africa (all income levels) to that in Sub-Saharan Africa (developing only)?
Your answer should be very brief. 1. What is the ratio of the Aid flow (current US$) in 1961 in Sub-Saharan Africa (all income levels) to that in Sub-Saharan Africa (developing only)?
Make the answer very short. 1. What is the ratio of the Aid flow (current US$) of 1960 in Sub-Saharan Africa (all income levels) to that in Upper middle income?
Provide a succinct answer. 0.86. What is the ratio of the Aid flow (current US$) in 1961 in Sub-Saharan Africa (all income levels) to that in Upper middle income?
Make the answer very short. 0.7. What is the ratio of the Aid flow (current US$) in 1962 in Sub-Saharan Africa (all income levels) to that in Upper middle income?
Provide a succinct answer. 0.9. What is the ratio of the Aid flow (current US$) in 1963 in Sub-Saharan Africa (all income levels) to that in Upper middle income?
Provide a short and direct response. 1.32. What is the ratio of the Aid flow (current US$) of 1960 in Sub-Saharan Africa (developing only) to that in Upper middle income?
Your response must be concise. 0.86. What is the ratio of the Aid flow (current US$) in 1961 in Sub-Saharan Africa (developing only) to that in Upper middle income?
Provide a succinct answer. 0.7. What is the ratio of the Aid flow (current US$) of 1962 in Sub-Saharan Africa (developing only) to that in Upper middle income?
Provide a short and direct response. 0.9. What is the ratio of the Aid flow (current US$) of 1963 in Sub-Saharan Africa (developing only) to that in Upper middle income?
Keep it short and to the point. 1.32. What is the difference between the highest and the second highest Aid flow (current US$) of 1960?
Give a very brief answer. 1.26e+07. What is the difference between the highest and the second highest Aid flow (current US$) in 1961?
Your answer should be compact. 0. What is the difference between the highest and the second highest Aid flow (current US$) in 1962?
Ensure brevity in your answer.  4.20e+06. What is the difference between the highest and the second highest Aid flow (current US$) in 1963?
Your answer should be compact. 0. What is the difference between the highest and the lowest Aid flow (current US$) of 1960?
Your answer should be compact. 9.03e+07. What is the difference between the highest and the lowest Aid flow (current US$) of 1961?
Ensure brevity in your answer.  1.60e+08. What is the difference between the highest and the lowest Aid flow (current US$) in 1962?
Make the answer very short. 8.13e+07. What is the difference between the highest and the lowest Aid flow (current US$) in 1963?
Offer a terse response. 8.17e+07. 